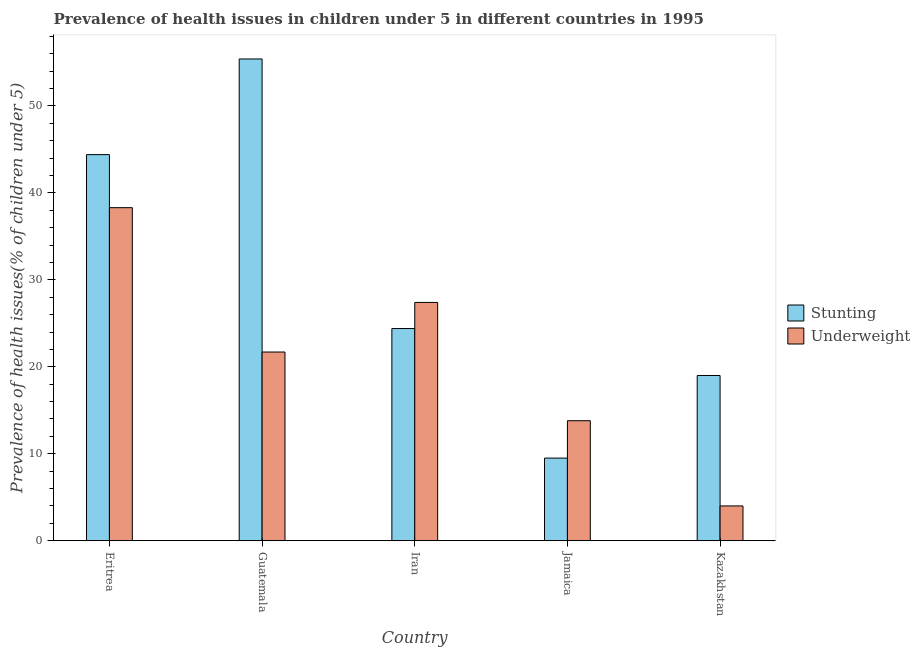Are the number of bars per tick equal to the number of legend labels?
Your answer should be very brief. Yes. How many bars are there on the 4th tick from the right?
Provide a succinct answer. 2. What is the label of the 4th group of bars from the left?
Your response must be concise. Jamaica. What is the percentage of underweight children in Iran?
Give a very brief answer. 27.4. Across all countries, what is the maximum percentage of underweight children?
Keep it short and to the point. 38.3. In which country was the percentage of underweight children maximum?
Your response must be concise. Eritrea. In which country was the percentage of underweight children minimum?
Make the answer very short. Kazakhstan. What is the total percentage of stunted children in the graph?
Make the answer very short. 152.7. What is the difference between the percentage of underweight children in Eritrea and the percentage of stunted children in Jamaica?
Your response must be concise. 28.8. What is the average percentage of stunted children per country?
Provide a short and direct response. 30.54. What is the difference between the percentage of underweight children and percentage of stunted children in Guatemala?
Ensure brevity in your answer.  -33.7. What is the ratio of the percentage of stunted children in Eritrea to that in Kazakhstan?
Offer a terse response. 2.34. What is the difference between the highest and the second highest percentage of stunted children?
Offer a terse response. 11. What is the difference between the highest and the lowest percentage of underweight children?
Your answer should be compact. 34.3. In how many countries, is the percentage of underweight children greater than the average percentage of underweight children taken over all countries?
Offer a very short reply. 3. What does the 2nd bar from the left in Iran represents?
Your answer should be very brief. Underweight. What does the 2nd bar from the right in Guatemala represents?
Keep it short and to the point. Stunting. How many bars are there?
Your answer should be compact. 10. What is the difference between two consecutive major ticks on the Y-axis?
Give a very brief answer. 10. Does the graph contain any zero values?
Give a very brief answer. No. What is the title of the graph?
Give a very brief answer. Prevalence of health issues in children under 5 in different countries in 1995. What is the label or title of the X-axis?
Make the answer very short. Country. What is the label or title of the Y-axis?
Offer a very short reply. Prevalence of health issues(% of children under 5). What is the Prevalence of health issues(% of children under 5) in Stunting in Eritrea?
Your answer should be very brief. 44.4. What is the Prevalence of health issues(% of children under 5) of Underweight in Eritrea?
Provide a short and direct response. 38.3. What is the Prevalence of health issues(% of children under 5) of Stunting in Guatemala?
Offer a terse response. 55.4. What is the Prevalence of health issues(% of children under 5) in Underweight in Guatemala?
Your answer should be compact. 21.7. What is the Prevalence of health issues(% of children under 5) in Stunting in Iran?
Provide a succinct answer. 24.4. What is the Prevalence of health issues(% of children under 5) of Underweight in Iran?
Your response must be concise. 27.4. What is the Prevalence of health issues(% of children under 5) in Stunting in Jamaica?
Give a very brief answer. 9.5. What is the Prevalence of health issues(% of children under 5) in Underweight in Jamaica?
Offer a terse response. 13.8. What is the Prevalence of health issues(% of children under 5) in Stunting in Kazakhstan?
Ensure brevity in your answer.  19. What is the Prevalence of health issues(% of children under 5) in Underweight in Kazakhstan?
Provide a succinct answer. 4. Across all countries, what is the maximum Prevalence of health issues(% of children under 5) in Stunting?
Offer a terse response. 55.4. Across all countries, what is the maximum Prevalence of health issues(% of children under 5) in Underweight?
Offer a very short reply. 38.3. Across all countries, what is the minimum Prevalence of health issues(% of children under 5) in Underweight?
Ensure brevity in your answer.  4. What is the total Prevalence of health issues(% of children under 5) in Stunting in the graph?
Provide a short and direct response. 152.7. What is the total Prevalence of health issues(% of children under 5) in Underweight in the graph?
Provide a short and direct response. 105.2. What is the difference between the Prevalence of health issues(% of children under 5) in Underweight in Eritrea and that in Guatemala?
Offer a very short reply. 16.6. What is the difference between the Prevalence of health issues(% of children under 5) in Stunting in Eritrea and that in Jamaica?
Your answer should be compact. 34.9. What is the difference between the Prevalence of health issues(% of children under 5) of Underweight in Eritrea and that in Jamaica?
Your answer should be very brief. 24.5. What is the difference between the Prevalence of health issues(% of children under 5) in Stunting in Eritrea and that in Kazakhstan?
Give a very brief answer. 25.4. What is the difference between the Prevalence of health issues(% of children under 5) in Underweight in Eritrea and that in Kazakhstan?
Provide a succinct answer. 34.3. What is the difference between the Prevalence of health issues(% of children under 5) of Stunting in Guatemala and that in Iran?
Offer a very short reply. 31. What is the difference between the Prevalence of health issues(% of children under 5) of Underweight in Guatemala and that in Iran?
Make the answer very short. -5.7. What is the difference between the Prevalence of health issues(% of children under 5) of Stunting in Guatemala and that in Jamaica?
Make the answer very short. 45.9. What is the difference between the Prevalence of health issues(% of children under 5) in Underweight in Guatemala and that in Jamaica?
Your answer should be very brief. 7.9. What is the difference between the Prevalence of health issues(% of children under 5) in Stunting in Guatemala and that in Kazakhstan?
Make the answer very short. 36.4. What is the difference between the Prevalence of health issues(% of children under 5) of Stunting in Iran and that in Jamaica?
Your answer should be very brief. 14.9. What is the difference between the Prevalence of health issues(% of children under 5) of Stunting in Iran and that in Kazakhstan?
Provide a short and direct response. 5.4. What is the difference between the Prevalence of health issues(% of children under 5) of Underweight in Iran and that in Kazakhstan?
Offer a very short reply. 23.4. What is the difference between the Prevalence of health issues(% of children under 5) of Stunting in Jamaica and that in Kazakhstan?
Offer a very short reply. -9.5. What is the difference between the Prevalence of health issues(% of children under 5) in Underweight in Jamaica and that in Kazakhstan?
Offer a terse response. 9.8. What is the difference between the Prevalence of health issues(% of children under 5) in Stunting in Eritrea and the Prevalence of health issues(% of children under 5) in Underweight in Guatemala?
Your answer should be compact. 22.7. What is the difference between the Prevalence of health issues(% of children under 5) of Stunting in Eritrea and the Prevalence of health issues(% of children under 5) of Underweight in Jamaica?
Provide a succinct answer. 30.6. What is the difference between the Prevalence of health issues(% of children under 5) of Stunting in Eritrea and the Prevalence of health issues(% of children under 5) of Underweight in Kazakhstan?
Provide a succinct answer. 40.4. What is the difference between the Prevalence of health issues(% of children under 5) in Stunting in Guatemala and the Prevalence of health issues(% of children under 5) in Underweight in Jamaica?
Offer a terse response. 41.6. What is the difference between the Prevalence of health issues(% of children under 5) of Stunting in Guatemala and the Prevalence of health issues(% of children under 5) of Underweight in Kazakhstan?
Make the answer very short. 51.4. What is the difference between the Prevalence of health issues(% of children under 5) of Stunting in Iran and the Prevalence of health issues(% of children under 5) of Underweight in Kazakhstan?
Provide a short and direct response. 20.4. What is the average Prevalence of health issues(% of children under 5) of Stunting per country?
Offer a terse response. 30.54. What is the average Prevalence of health issues(% of children under 5) of Underweight per country?
Provide a succinct answer. 21.04. What is the difference between the Prevalence of health issues(% of children under 5) in Stunting and Prevalence of health issues(% of children under 5) in Underweight in Guatemala?
Provide a short and direct response. 33.7. What is the difference between the Prevalence of health issues(% of children under 5) in Stunting and Prevalence of health issues(% of children under 5) in Underweight in Iran?
Make the answer very short. -3. What is the difference between the Prevalence of health issues(% of children under 5) in Stunting and Prevalence of health issues(% of children under 5) in Underweight in Kazakhstan?
Provide a succinct answer. 15. What is the ratio of the Prevalence of health issues(% of children under 5) in Stunting in Eritrea to that in Guatemala?
Offer a terse response. 0.8. What is the ratio of the Prevalence of health issues(% of children under 5) of Underweight in Eritrea to that in Guatemala?
Offer a terse response. 1.76. What is the ratio of the Prevalence of health issues(% of children under 5) in Stunting in Eritrea to that in Iran?
Provide a succinct answer. 1.82. What is the ratio of the Prevalence of health issues(% of children under 5) of Underweight in Eritrea to that in Iran?
Your answer should be compact. 1.4. What is the ratio of the Prevalence of health issues(% of children under 5) of Stunting in Eritrea to that in Jamaica?
Provide a short and direct response. 4.67. What is the ratio of the Prevalence of health issues(% of children under 5) in Underweight in Eritrea to that in Jamaica?
Your answer should be compact. 2.78. What is the ratio of the Prevalence of health issues(% of children under 5) of Stunting in Eritrea to that in Kazakhstan?
Give a very brief answer. 2.34. What is the ratio of the Prevalence of health issues(% of children under 5) of Underweight in Eritrea to that in Kazakhstan?
Offer a terse response. 9.57. What is the ratio of the Prevalence of health issues(% of children under 5) of Stunting in Guatemala to that in Iran?
Give a very brief answer. 2.27. What is the ratio of the Prevalence of health issues(% of children under 5) in Underweight in Guatemala to that in Iran?
Provide a short and direct response. 0.79. What is the ratio of the Prevalence of health issues(% of children under 5) of Stunting in Guatemala to that in Jamaica?
Keep it short and to the point. 5.83. What is the ratio of the Prevalence of health issues(% of children under 5) in Underweight in Guatemala to that in Jamaica?
Make the answer very short. 1.57. What is the ratio of the Prevalence of health issues(% of children under 5) of Stunting in Guatemala to that in Kazakhstan?
Your response must be concise. 2.92. What is the ratio of the Prevalence of health issues(% of children under 5) in Underweight in Guatemala to that in Kazakhstan?
Your answer should be compact. 5.42. What is the ratio of the Prevalence of health issues(% of children under 5) in Stunting in Iran to that in Jamaica?
Give a very brief answer. 2.57. What is the ratio of the Prevalence of health issues(% of children under 5) in Underweight in Iran to that in Jamaica?
Keep it short and to the point. 1.99. What is the ratio of the Prevalence of health issues(% of children under 5) in Stunting in Iran to that in Kazakhstan?
Your answer should be compact. 1.28. What is the ratio of the Prevalence of health issues(% of children under 5) in Underweight in Iran to that in Kazakhstan?
Offer a terse response. 6.85. What is the ratio of the Prevalence of health issues(% of children under 5) in Underweight in Jamaica to that in Kazakhstan?
Offer a terse response. 3.45. What is the difference between the highest and the second highest Prevalence of health issues(% of children under 5) of Underweight?
Give a very brief answer. 10.9. What is the difference between the highest and the lowest Prevalence of health issues(% of children under 5) of Stunting?
Keep it short and to the point. 45.9. What is the difference between the highest and the lowest Prevalence of health issues(% of children under 5) of Underweight?
Ensure brevity in your answer.  34.3. 